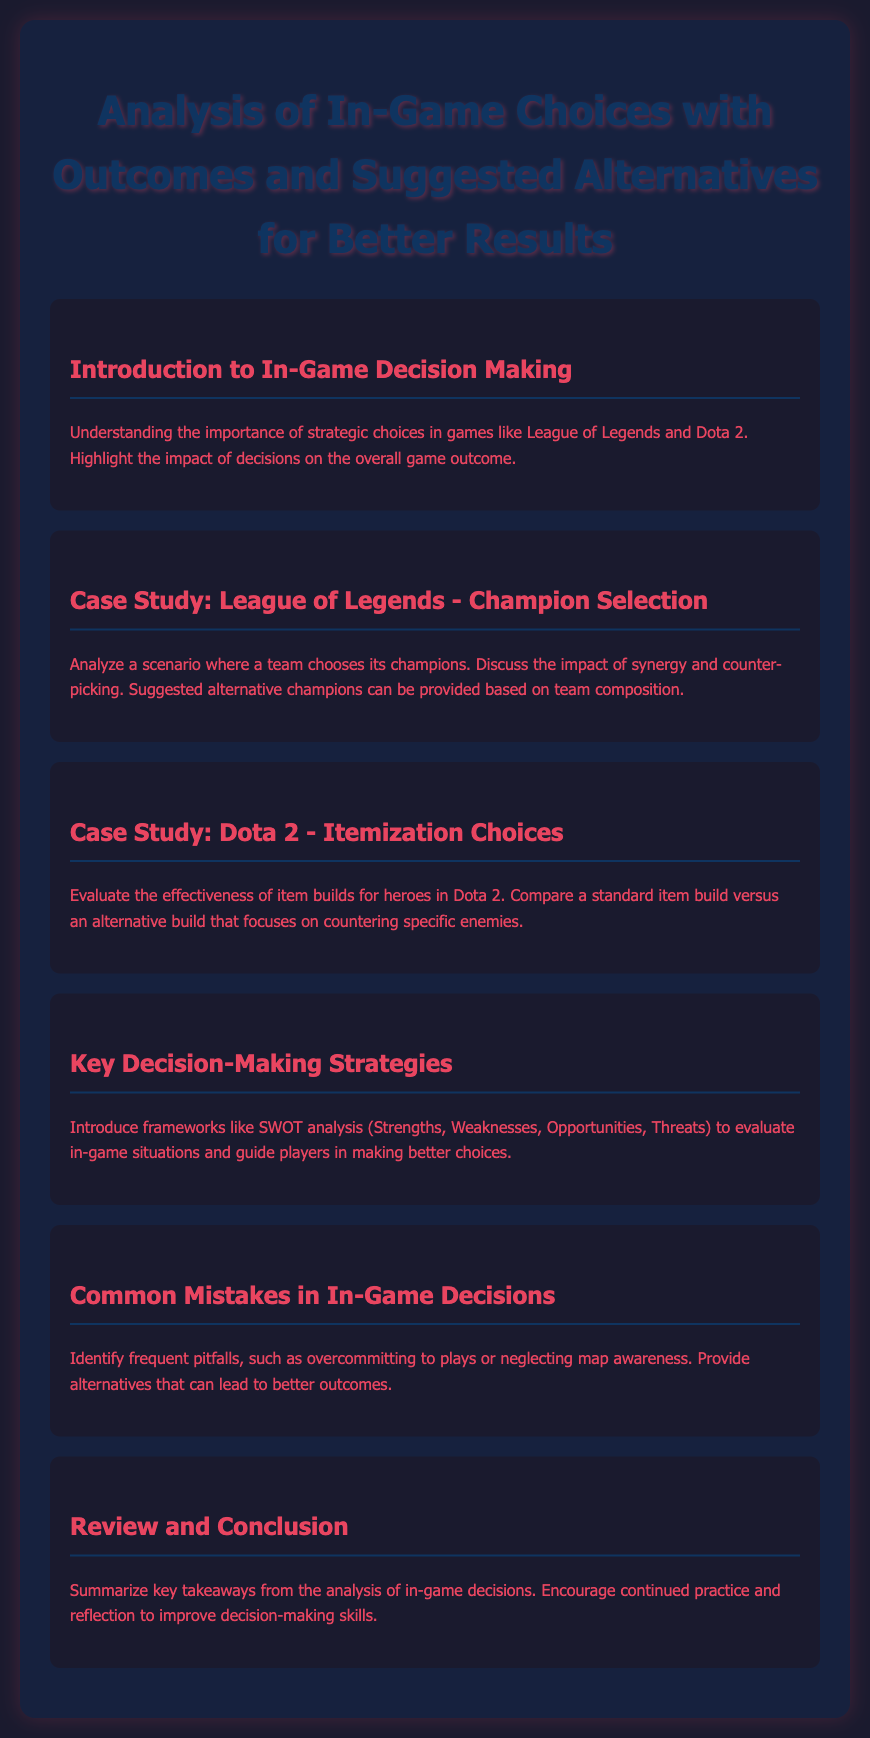what is the title of the document? The title of the document is highlighted in the header section, it is the first line text.
Answer: Analysis of In-Game Choices with Outcomes and Suggested Alternatives for Better Results what is the first section of the document? The first section introduces the importance of strategic choices in games, as noted in the content of the section.
Answer: Introduction to In-Game Decision Making which game is analyzed in the case study for champion selection? The document explicitly mentions a specific game in this section title.
Answer: League of Legends what analytical framework is introduced in the key decision-making strategies section? The document refers to a framework that helps evaluate situations, as stated in that section.
Answer: SWOT analysis what common mistake is identified related to in-game decisions? The document points out one specific mistake that players often make, as highlighted in the section.
Answer: Overcommitting to plays how many case studies are included in the document? The document lists specific case studies, and the number can be counted from the given sections.
Answer: Two 